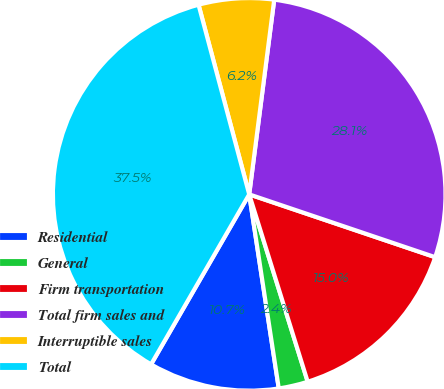<chart> <loc_0><loc_0><loc_500><loc_500><pie_chart><fcel>Residential<fcel>General<fcel>Firm transportation<fcel>Total firm sales and<fcel>Interruptible sales<fcel>Total<nl><fcel>10.74%<fcel>2.41%<fcel>15.0%<fcel>28.15%<fcel>6.19%<fcel>37.51%<nl></chart> 